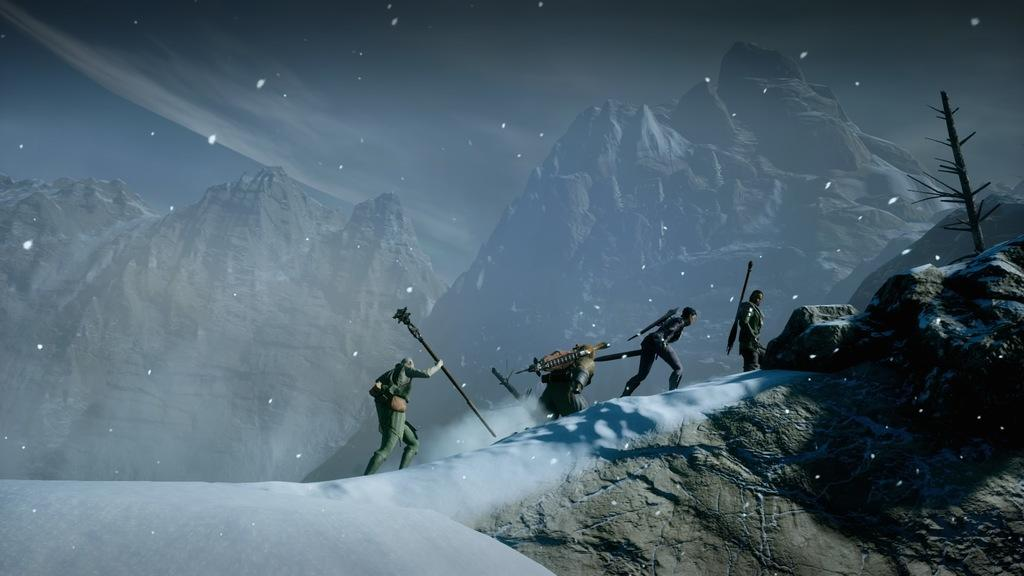What type of image is present in the picture? There is a graphical image in the picture. Can you describe the people in the image? There are people in the image. What is the terrain the people are standing on? The people are on snow. What can be seen in the background of the image? There are mountains in the background of the image. Are there any masks being used by the people in the image? There is no mention of masks in the image, so we cannot determine if they are being used. 